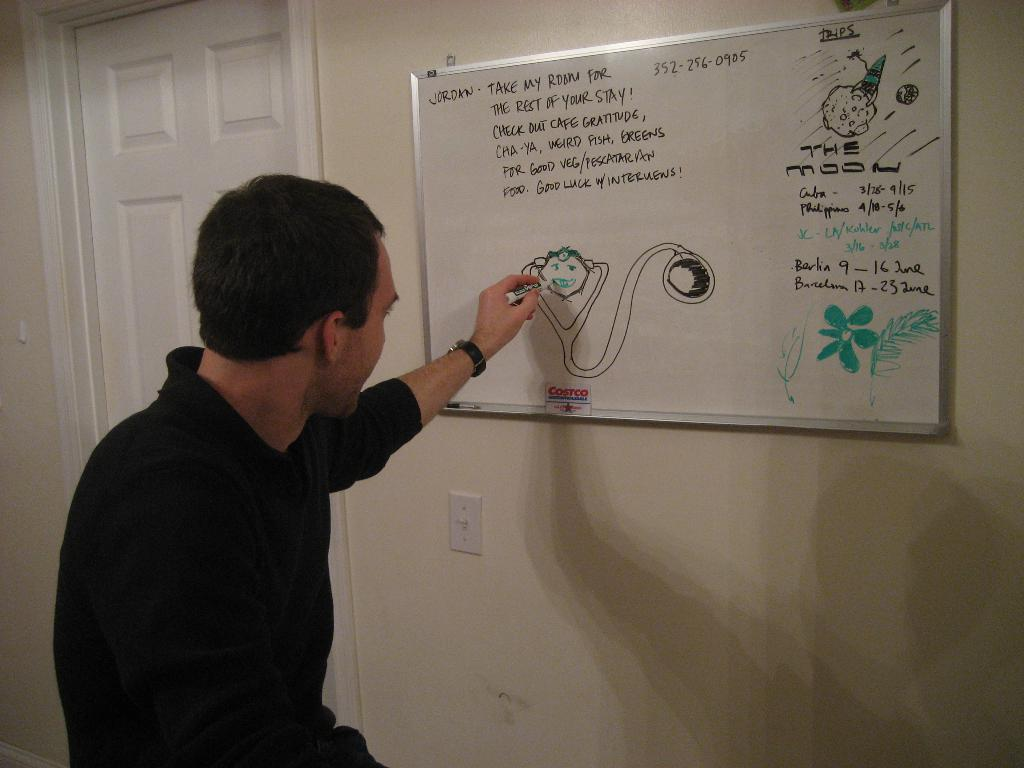<image>
Create a compact narrative representing the image presented. A man is drawing a picture on a white board that says Jordan take my room for the rest of your stay at the top. 